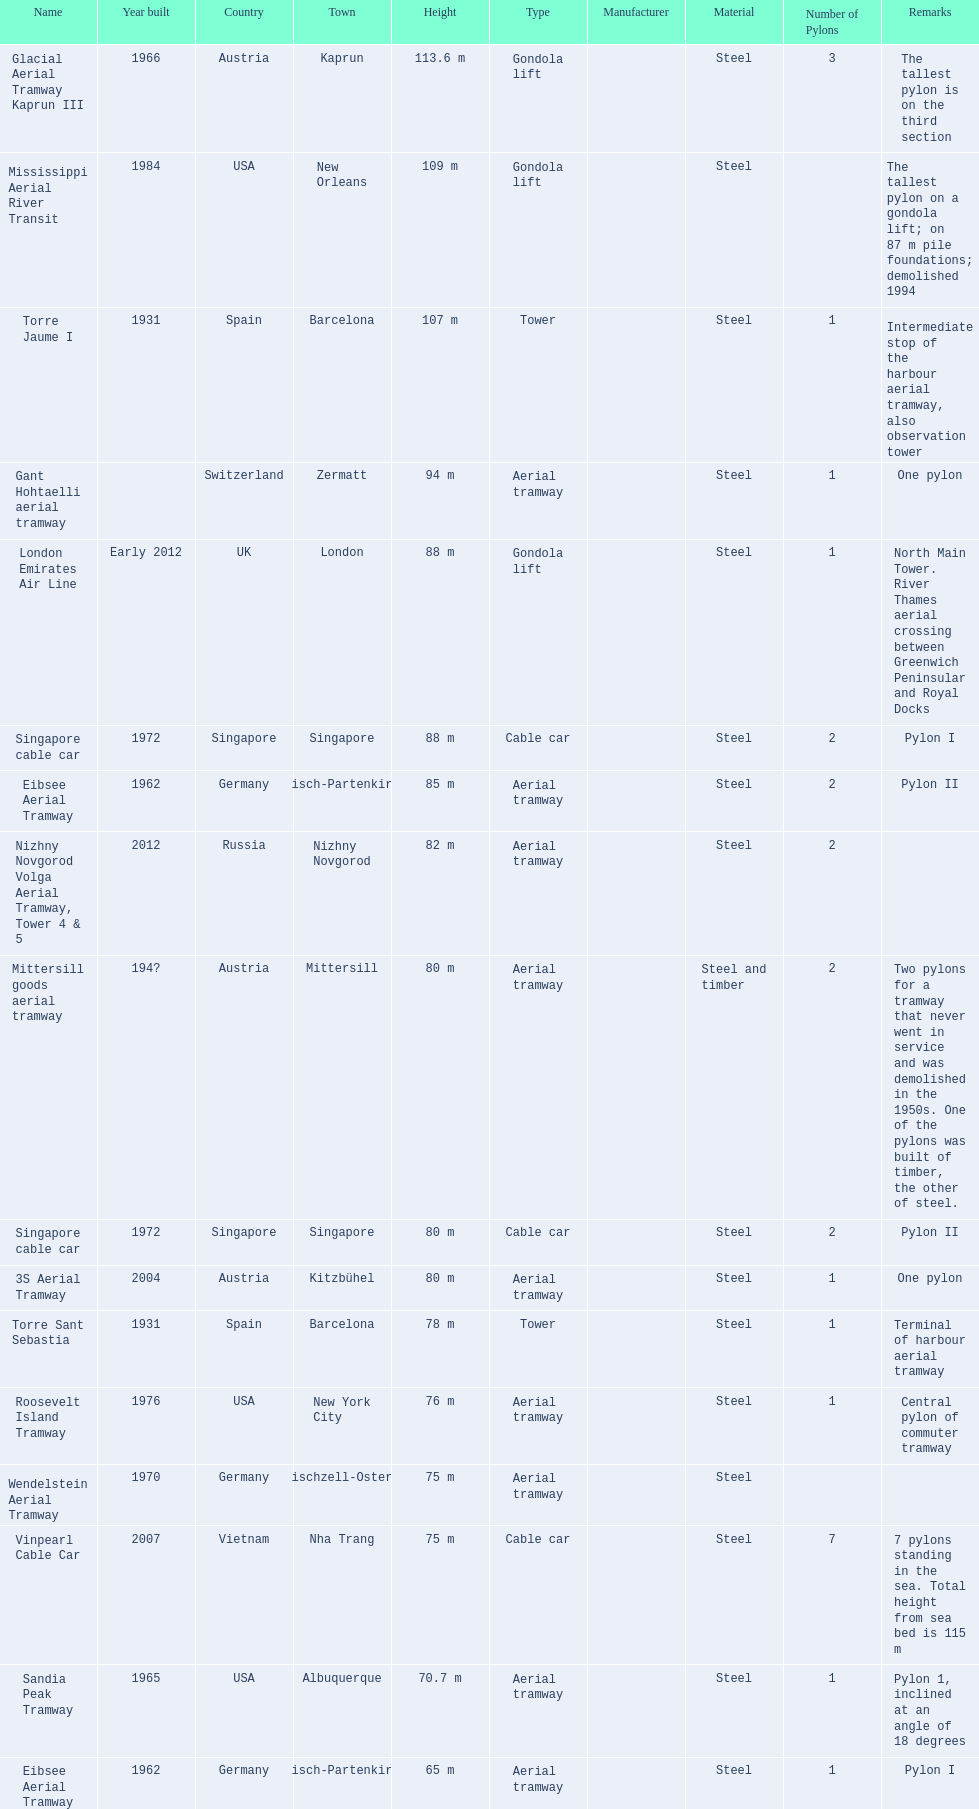Which pylon is the least tall? Eibsee Aerial Tramway. Parse the full table. {'header': ['Name', 'Year built', 'Country', 'Town', 'Height', 'Type', 'Manufacturer', 'Material', 'Number of Pylons', 'Remarks'], 'rows': [['Glacial Aerial Tramway Kaprun III', '1966', 'Austria', 'Kaprun', '113.6 m', 'Gondola lift', '', 'Steel', '3', 'The tallest pylon is on the third section'], ['Mississippi Aerial River Transit', '1984', 'USA', 'New Orleans', '109 m', 'Gondola lift', '', 'Steel', '', 'The tallest pylon on a gondola lift; on 87 m pile foundations; demolished 1994'], ['Torre Jaume I', '1931', 'Spain', 'Barcelona', '107 m', 'Tower', '', 'Steel', '1', 'Intermediate stop of the harbour aerial tramway, also observation tower'], ['Gant Hohtaelli aerial tramway', '', 'Switzerland', 'Zermatt', '94 m', 'Aerial tramway', '', 'Steel', '1', 'One pylon'], ['London Emirates Air Line', 'Early 2012', 'UK', 'London', '88 m', 'Gondola lift', '', 'Steel', '1', 'North Main Tower. River Thames aerial crossing between Greenwich Peninsular and Royal Docks'], ['Singapore cable car', '1972', 'Singapore', 'Singapore', '88 m', 'Cable car', '', 'Steel', '2', 'Pylon I'], ['Eibsee Aerial Tramway', '1962', 'Germany', 'Garmisch-Partenkirchen', '85 m', 'Aerial tramway', '', 'Steel', '2', 'Pylon II'], ['Nizhny Novgorod Volga Aerial Tramway, Tower 4 & 5', '2012', 'Russia', 'Nizhny Novgorod', '82 m', 'Aerial tramway', '', 'Steel', '2', ''], ['Mittersill goods aerial tramway', '194?', 'Austria', 'Mittersill', '80 m', 'Aerial tramway', '', 'Steel and timber', '2', 'Two pylons for a tramway that never went in service and was demolished in the 1950s. One of the pylons was built of timber, the other of steel.'], ['Singapore cable car', '1972', 'Singapore', 'Singapore', '80 m', 'Cable car', '', 'Steel', '2', 'Pylon II'], ['3S Aerial Tramway', '2004', 'Austria', 'Kitzbühel', '80 m', 'Aerial tramway', '', 'Steel', '1', 'One pylon'], ['Torre Sant Sebastia', '1931', 'Spain', 'Barcelona', '78 m', 'Tower', '', 'Steel', '1', 'Terminal of harbour aerial tramway'], ['Roosevelt Island Tramway', '1976', 'USA', 'New York City', '76 m', 'Aerial tramway', '', 'Steel', '1', 'Central pylon of commuter tramway'], ['Wendelstein Aerial Tramway', '1970', 'Germany', 'Bayerischzell-Osterhofen', '75 m', 'Aerial tramway', '', 'Steel', '', ''], ['Vinpearl Cable Car', '2007', 'Vietnam', 'Nha Trang', '75 m', 'Cable car', '', 'Steel', '7', '7 pylons standing in the sea. Total height from sea bed is 115 m'], ['Sandia Peak Tramway', '1965', 'USA', 'Albuquerque', '70.7 m', 'Aerial tramway', '', 'Steel', '1', 'Pylon 1, inclined at an angle of 18 degrees'], ['Eibsee Aerial Tramway', '1962', 'Germany', 'Garmisch-Partenkirchen', '65 m', 'Aerial tramway', '', 'Steel', '1', 'Pylon I']]} 